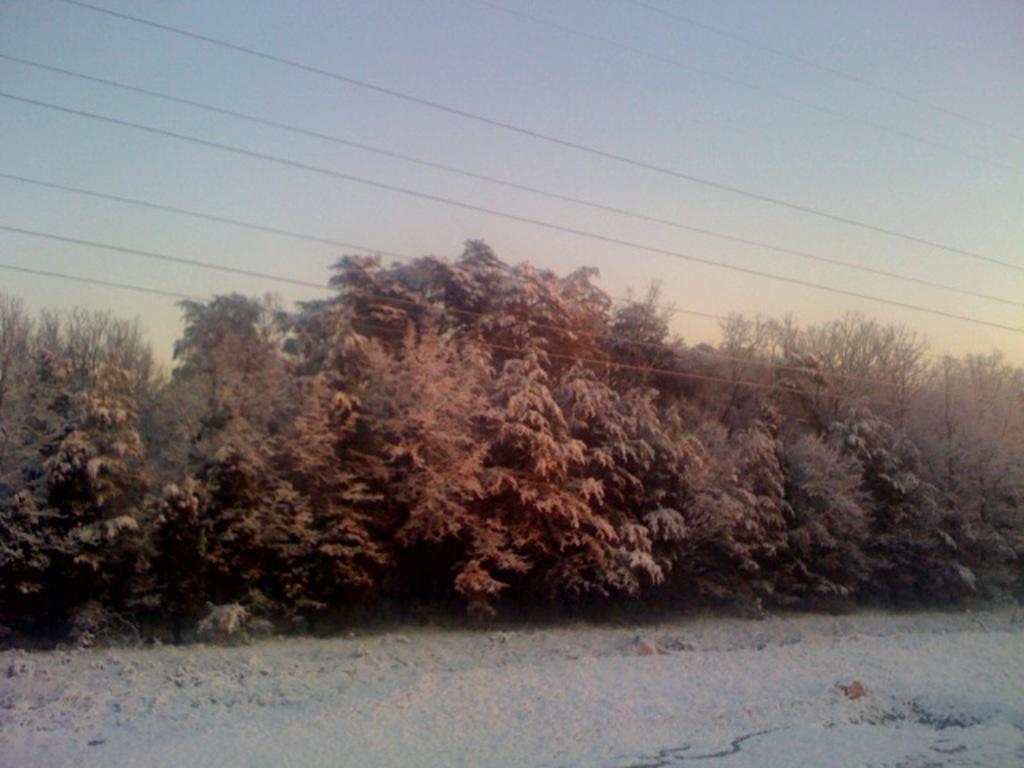How would you summarize this image in a sentence or two? In this image I can see at the bottom there is the snow. In the middle there are green trees and there are electric cables, at the top it is the sky. 